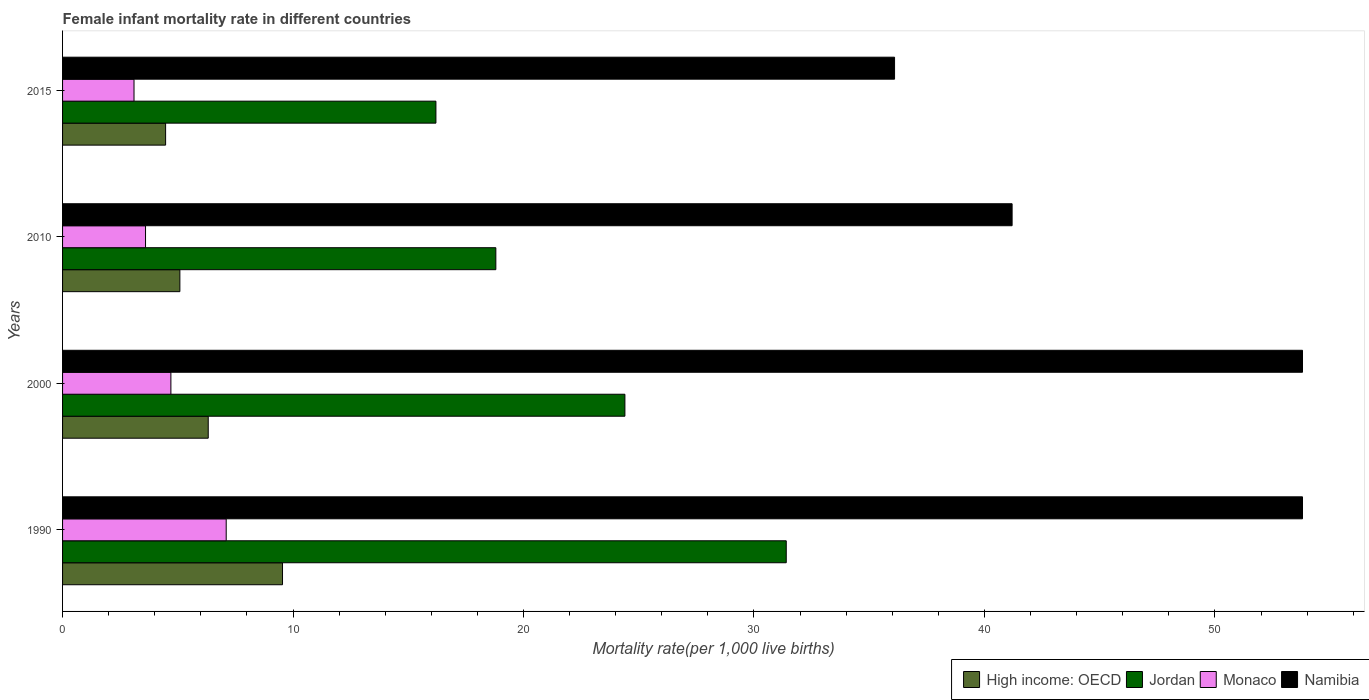How many different coloured bars are there?
Make the answer very short. 4. Are the number of bars per tick equal to the number of legend labels?
Make the answer very short. Yes. How many bars are there on the 3rd tick from the top?
Keep it short and to the point. 4. How many bars are there on the 2nd tick from the bottom?
Give a very brief answer. 4. What is the label of the 4th group of bars from the top?
Give a very brief answer. 1990. In how many cases, is the number of bars for a given year not equal to the number of legend labels?
Offer a terse response. 0. Across all years, what is the maximum female infant mortality rate in Monaco?
Provide a short and direct response. 7.1. Across all years, what is the minimum female infant mortality rate in High income: OECD?
Make the answer very short. 4.47. In which year was the female infant mortality rate in High income: OECD maximum?
Offer a terse response. 1990. In which year was the female infant mortality rate in High income: OECD minimum?
Provide a succinct answer. 2015. What is the total female infant mortality rate in High income: OECD in the graph?
Provide a succinct answer. 25.42. What is the difference between the female infant mortality rate in Jordan in 2000 and that in 2010?
Give a very brief answer. 5.6. What is the difference between the female infant mortality rate in Monaco in 1990 and the female infant mortality rate in Jordan in 2015?
Your answer should be very brief. -9.1. What is the average female infant mortality rate in Monaco per year?
Your response must be concise. 4.62. In the year 2000, what is the difference between the female infant mortality rate in Jordan and female infant mortality rate in High income: OECD?
Ensure brevity in your answer.  18.08. In how many years, is the female infant mortality rate in Namibia greater than 22 ?
Make the answer very short. 4. What is the ratio of the female infant mortality rate in Monaco in 1990 to that in 2010?
Ensure brevity in your answer.  1.97. Is the female infant mortality rate in Monaco in 1990 less than that in 2000?
Your answer should be compact. No. Is the difference between the female infant mortality rate in Jordan in 1990 and 2000 greater than the difference between the female infant mortality rate in High income: OECD in 1990 and 2000?
Provide a succinct answer. Yes. What is the difference between the highest and the second highest female infant mortality rate in Namibia?
Your answer should be compact. 0. What is the difference between the highest and the lowest female infant mortality rate in High income: OECD?
Give a very brief answer. 5.07. In how many years, is the female infant mortality rate in Jordan greater than the average female infant mortality rate in Jordan taken over all years?
Your response must be concise. 2. Is the sum of the female infant mortality rate in Namibia in 1990 and 2015 greater than the maximum female infant mortality rate in High income: OECD across all years?
Your answer should be very brief. Yes. What does the 2nd bar from the top in 2000 represents?
Give a very brief answer. Monaco. What does the 2nd bar from the bottom in 2010 represents?
Your answer should be compact. Jordan. Is it the case that in every year, the sum of the female infant mortality rate in Namibia and female infant mortality rate in High income: OECD is greater than the female infant mortality rate in Monaco?
Your answer should be very brief. Yes. How many bars are there?
Provide a short and direct response. 16. Are all the bars in the graph horizontal?
Offer a terse response. Yes. How many years are there in the graph?
Provide a succinct answer. 4. What is the difference between two consecutive major ticks on the X-axis?
Your answer should be compact. 10. Are the values on the major ticks of X-axis written in scientific E-notation?
Your answer should be very brief. No. Does the graph contain any zero values?
Your response must be concise. No. Does the graph contain grids?
Your response must be concise. No. What is the title of the graph?
Your answer should be compact. Female infant mortality rate in different countries. Does "Fragile and conflict affected situations" appear as one of the legend labels in the graph?
Your response must be concise. No. What is the label or title of the X-axis?
Keep it short and to the point. Mortality rate(per 1,0 live births). What is the Mortality rate(per 1,000 live births) of High income: OECD in 1990?
Your answer should be compact. 9.54. What is the Mortality rate(per 1,000 live births) of Jordan in 1990?
Keep it short and to the point. 31.4. What is the Mortality rate(per 1,000 live births) in Monaco in 1990?
Provide a short and direct response. 7.1. What is the Mortality rate(per 1,000 live births) in Namibia in 1990?
Your response must be concise. 53.8. What is the Mortality rate(per 1,000 live births) of High income: OECD in 2000?
Your response must be concise. 6.32. What is the Mortality rate(per 1,000 live births) in Jordan in 2000?
Your response must be concise. 24.4. What is the Mortality rate(per 1,000 live births) in Namibia in 2000?
Offer a very short reply. 53.8. What is the Mortality rate(per 1,000 live births) of High income: OECD in 2010?
Your response must be concise. 5.09. What is the Mortality rate(per 1,000 live births) of Jordan in 2010?
Keep it short and to the point. 18.8. What is the Mortality rate(per 1,000 live births) of Namibia in 2010?
Offer a very short reply. 41.2. What is the Mortality rate(per 1,000 live births) of High income: OECD in 2015?
Make the answer very short. 4.47. What is the Mortality rate(per 1,000 live births) in Jordan in 2015?
Your answer should be compact. 16.2. What is the Mortality rate(per 1,000 live births) in Namibia in 2015?
Your answer should be compact. 36.1. Across all years, what is the maximum Mortality rate(per 1,000 live births) in High income: OECD?
Offer a very short reply. 9.54. Across all years, what is the maximum Mortality rate(per 1,000 live births) of Jordan?
Your answer should be very brief. 31.4. Across all years, what is the maximum Mortality rate(per 1,000 live births) in Namibia?
Offer a very short reply. 53.8. Across all years, what is the minimum Mortality rate(per 1,000 live births) of High income: OECD?
Your answer should be compact. 4.47. Across all years, what is the minimum Mortality rate(per 1,000 live births) of Monaco?
Your response must be concise. 3.1. Across all years, what is the minimum Mortality rate(per 1,000 live births) of Namibia?
Your response must be concise. 36.1. What is the total Mortality rate(per 1,000 live births) in High income: OECD in the graph?
Your answer should be very brief. 25.42. What is the total Mortality rate(per 1,000 live births) in Jordan in the graph?
Your answer should be very brief. 90.8. What is the total Mortality rate(per 1,000 live births) in Namibia in the graph?
Offer a terse response. 184.9. What is the difference between the Mortality rate(per 1,000 live births) in High income: OECD in 1990 and that in 2000?
Provide a short and direct response. 3.22. What is the difference between the Mortality rate(per 1,000 live births) in Jordan in 1990 and that in 2000?
Offer a very short reply. 7. What is the difference between the Mortality rate(per 1,000 live births) in Monaco in 1990 and that in 2000?
Give a very brief answer. 2.4. What is the difference between the Mortality rate(per 1,000 live births) in Namibia in 1990 and that in 2000?
Provide a short and direct response. 0. What is the difference between the Mortality rate(per 1,000 live births) in High income: OECD in 1990 and that in 2010?
Your answer should be compact. 4.45. What is the difference between the Mortality rate(per 1,000 live births) of Jordan in 1990 and that in 2010?
Make the answer very short. 12.6. What is the difference between the Mortality rate(per 1,000 live births) of Monaco in 1990 and that in 2010?
Your answer should be compact. 3.5. What is the difference between the Mortality rate(per 1,000 live births) of Namibia in 1990 and that in 2010?
Provide a short and direct response. 12.6. What is the difference between the Mortality rate(per 1,000 live births) in High income: OECD in 1990 and that in 2015?
Keep it short and to the point. 5.07. What is the difference between the Mortality rate(per 1,000 live births) of Namibia in 1990 and that in 2015?
Offer a very short reply. 17.7. What is the difference between the Mortality rate(per 1,000 live births) of High income: OECD in 2000 and that in 2010?
Provide a succinct answer. 1.23. What is the difference between the Mortality rate(per 1,000 live births) in Namibia in 2000 and that in 2010?
Make the answer very short. 12.6. What is the difference between the Mortality rate(per 1,000 live births) in High income: OECD in 2000 and that in 2015?
Your answer should be very brief. 1.85. What is the difference between the Mortality rate(per 1,000 live births) in Namibia in 2000 and that in 2015?
Keep it short and to the point. 17.7. What is the difference between the Mortality rate(per 1,000 live births) of High income: OECD in 2010 and that in 2015?
Give a very brief answer. 0.62. What is the difference between the Mortality rate(per 1,000 live births) in Jordan in 2010 and that in 2015?
Provide a short and direct response. 2.6. What is the difference between the Mortality rate(per 1,000 live births) of High income: OECD in 1990 and the Mortality rate(per 1,000 live births) of Jordan in 2000?
Give a very brief answer. -14.86. What is the difference between the Mortality rate(per 1,000 live births) in High income: OECD in 1990 and the Mortality rate(per 1,000 live births) in Monaco in 2000?
Offer a very short reply. 4.84. What is the difference between the Mortality rate(per 1,000 live births) of High income: OECD in 1990 and the Mortality rate(per 1,000 live births) of Namibia in 2000?
Make the answer very short. -44.26. What is the difference between the Mortality rate(per 1,000 live births) in Jordan in 1990 and the Mortality rate(per 1,000 live births) in Monaco in 2000?
Your response must be concise. 26.7. What is the difference between the Mortality rate(per 1,000 live births) in Jordan in 1990 and the Mortality rate(per 1,000 live births) in Namibia in 2000?
Your answer should be very brief. -22.4. What is the difference between the Mortality rate(per 1,000 live births) in Monaco in 1990 and the Mortality rate(per 1,000 live births) in Namibia in 2000?
Provide a succinct answer. -46.7. What is the difference between the Mortality rate(per 1,000 live births) of High income: OECD in 1990 and the Mortality rate(per 1,000 live births) of Jordan in 2010?
Make the answer very short. -9.26. What is the difference between the Mortality rate(per 1,000 live births) in High income: OECD in 1990 and the Mortality rate(per 1,000 live births) in Monaco in 2010?
Offer a terse response. 5.94. What is the difference between the Mortality rate(per 1,000 live births) in High income: OECD in 1990 and the Mortality rate(per 1,000 live births) in Namibia in 2010?
Make the answer very short. -31.66. What is the difference between the Mortality rate(per 1,000 live births) of Jordan in 1990 and the Mortality rate(per 1,000 live births) of Monaco in 2010?
Keep it short and to the point. 27.8. What is the difference between the Mortality rate(per 1,000 live births) in Jordan in 1990 and the Mortality rate(per 1,000 live births) in Namibia in 2010?
Your answer should be very brief. -9.8. What is the difference between the Mortality rate(per 1,000 live births) in Monaco in 1990 and the Mortality rate(per 1,000 live births) in Namibia in 2010?
Keep it short and to the point. -34.1. What is the difference between the Mortality rate(per 1,000 live births) in High income: OECD in 1990 and the Mortality rate(per 1,000 live births) in Jordan in 2015?
Give a very brief answer. -6.66. What is the difference between the Mortality rate(per 1,000 live births) in High income: OECD in 1990 and the Mortality rate(per 1,000 live births) in Monaco in 2015?
Provide a succinct answer. 6.44. What is the difference between the Mortality rate(per 1,000 live births) of High income: OECD in 1990 and the Mortality rate(per 1,000 live births) of Namibia in 2015?
Make the answer very short. -26.56. What is the difference between the Mortality rate(per 1,000 live births) of Jordan in 1990 and the Mortality rate(per 1,000 live births) of Monaco in 2015?
Keep it short and to the point. 28.3. What is the difference between the Mortality rate(per 1,000 live births) in Jordan in 1990 and the Mortality rate(per 1,000 live births) in Namibia in 2015?
Give a very brief answer. -4.7. What is the difference between the Mortality rate(per 1,000 live births) in Monaco in 1990 and the Mortality rate(per 1,000 live births) in Namibia in 2015?
Keep it short and to the point. -29. What is the difference between the Mortality rate(per 1,000 live births) in High income: OECD in 2000 and the Mortality rate(per 1,000 live births) in Jordan in 2010?
Make the answer very short. -12.48. What is the difference between the Mortality rate(per 1,000 live births) in High income: OECD in 2000 and the Mortality rate(per 1,000 live births) in Monaco in 2010?
Your response must be concise. 2.72. What is the difference between the Mortality rate(per 1,000 live births) of High income: OECD in 2000 and the Mortality rate(per 1,000 live births) of Namibia in 2010?
Offer a terse response. -34.88. What is the difference between the Mortality rate(per 1,000 live births) in Jordan in 2000 and the Mortality rate(per 1,000 live births) in Monaco in 2010?
Give a very brief answer. 20.8. What is the difference between the Mortality rate(per 1,000 live births) of Jordan in 2000 and the Mortality rate(per 1,000 live births) of Namibia in 2010?
Your response must be concise. -16.8. What is the difference between the Mortality rate(per 1,000 live births) in Monaco in 2000 and the Mortality rate(per 1,000 live births) in Namibia in 2010?
Keep it short and to the point. -36.5. What is the difference between the Mortality rate(per 1,000 live births) of High income: OECD in 2000 and the Mortality rate(per 1,000 live births) of Jordan in 2015?
Your response must be concise. -9.88. What is the difference between the Mortality rate(per 1,000 live births) in High income: OECD in 2000 and the Mortality rate(per 1,000 live births) in Monaco in 2015?
Provide a short and direct response. 3.22. What is the difference between the Mortality rate(per 1,000 live births) of High income: OECD in 2000 and the Mortality rate(per 1,000 live births) of Namibia in 2015?
Give a very brief answer. -29.78. What is the difference between the Mortality rate(per 1,000 live births) of Jordan in 2000 and the Mortality rate(per 1,000 live births) of Monaco in 2015?
Ensure brevity in your answer.  21.3. What is the difference between the Mortality rate(per 1,000 live births) of Jordan in 2000 and the Mortality rate(per 1,000 live births) of Namibia in 2015?
Your answer should be compact. -11.7. What is the difference between the Mortality rate(per 1,000 live births) of Monaco in 2000 and the Mortality rate(per 1,000 live births) of Namibia in 2015?
Offer a very short reply. -31.4. What is the difference between the Mortality rate(per 1,000 live births) in High income: OECD in 2010 and the Mortality rate(per 1,000 live births) in Jordan in 2015?
Provide a short and direct response. -11.11. What is the difference between the Mortality rate(per 1,000 live births) of High income: OECD in 2010 and the Mortality rate(per 1,000 live births) of Monaco in 2015?
Keep it short and to the point. 1.99. What is the difference between the Mortality rate(per 1,000 live births) in High income: OECD in 2010 and the Mortality rate(per 1,000 live births) in Namibia in 2015?
Your answer should be compact. -31.01. What is the difference between the Mortality rate(per 1,000 live births) in Jordan in 2010 and the Mortality rate(per 1,000 live births) in Namibia in 2015?
Your answer should be compact. -17.3. What is the difference between the Mortality rate(per 1,000 live births) of Monaco in 2010 and the Mortality rate(per 1,000 live births) of Namibia in 2015?
Offer a very short reply. -32.5. What is the average Mortality rate(per 1,000 live births) of High income: OECD per year?
Give a very brief answer. 6.36. What is the average Mortality rate(per 1,000 live births) in Jordan per year?
Ensure brevity in your answer.  22.7. What is the average Mortality rate(per 1,000 live births) of Monaco per year?
Provide a short and direct response. 4.62. What is the average Mortality rate(per 1,000 live births) in Namibia per year?
Ensure brevity in your answer.  46.23. In the year 1990, what is the difference between the Mortality rate(per 1,000 live births) of High income: OECD and Mortality rate(per 1,000 live births) of Jordan?
Provide a short and direct response. -21.86. In the year 1990, what is the difference between the Mortality rate(per 1,000 live births) of High income: OECD and Mortality rate(per 1,000 live births) of Monaco?
Offer a very short reply. 2.44. In the year 1990, what is the difference between the Mortality rate(per 1,000 live births) in High income: OECD and Mortality rate(per 1,000 live births) in Namibia?
Give a very brief answer. -44.26. In the year 1990, what is the difference between the Mortality rate(per 1,000 live births) of Jordan and Mortality rate(per 1,000 live births) of Monaco?
Make the answer very short. 24.3. In the year 1990, what is the difference between the Mortality rate(per 1,000 live births) in Jordan and Mortality rate(per 1,000 live births) in Namibia?
Make the answer very short. -22.4. In the year 1990, what is the difference between the Mortality rate(per 1,000 live births) in Monaco and Mortality rate(per 1,000 live births) in Namibia?
Your answer should be very brief. -46.7. In the year 2000, what is the difference between the Mortality rate(per 1,000 live births) of High income: OECD and Mortality rate(per 1,000 live births) of Jordan?
Make the answer very short. -18.08. In the year 2000, what is the difference between the Mortality rate(per 1,000 live births) of High income: OECD and Mortality rate(per 1,000 live births) of Monaco?
Your response must be concise. 1.62. In the year 2000, what is the difference between the Mortality rate(per 1,000 live births) of High income: OECD and Mortality rate(per 1,000 live births) of Namibia?
Your answer should be compact. -47.48. In the year 2000, what is the difference between the Mortality rate(per 1,000 live births) in Jordan and Mortality rate(per 1,000 live births) in Monaco?
Your answer should be compact. 19.7. In the year 2000, what is the difference between the Mortality rate(per 1,000 live births) of Jordan and Mortality rate(per 1,000 live births) of Namibia?
Make the answer very short. -29.4. In the year 2000, what is the difference between the Mortality rate(per 1,000 live births) in Monaco and Mortality rate(per 1,000 live births) in Namibia?
Provide a short and direct response. -49.1. In the year 2010, what is the difference between the Mortality rate(per 1,000 live births) of High income: OECD and Mortality rate(per 1,000 live births) of Jordan?
Your answer should be very brief. -13.71. In the year 2010, what is the difference between the Mortality rate(per 1,000 live births) of High income: OECD and Mortality rate(per 1,000 live births) of Monaco?
Ensure brevity in your answer.  1.49. In the year 2010, what is the difference between the Mortality rate(per 1,000 live births) of High income: OECD and Mortality rate(per 1,000 live births) of Namibia?
Your answer should be very brief. -36.11. In the year 2010, what is the difference between the Mortality rate(per 1,000 live births) of Jordan and Mortality rate(per 1,000 live births) of Namibia?
Keep it short and to the point. -22.4. In the year 2010, what is the difference between the Mortality rate(per 1,000 live births) in Monaco and Mortality rate(per 1,000 live births) in Namibia?
Offer a very short reply. -37.6. In the year 2015, what is the difference between the Mortality rate(per 1,000 live births) in High income: OECD and Mortality rate(per 1,000 live births) in Jordan?
Your answer should be very brief. -11.73. In the year 2015, what is the difference between the Mortality rate(per 1,000 live births) of High income: OECD and Mortality rate(per 1,000 live births) of Monaco?
Offer a terse response. 1.37. In the year 2015, what is the difference between the Mortality rate(per 1,000 live births) of High income: OECD and Mortality rate(per 1,000 live births) of Namibia?
Offer a terse response. -31.63. In the year 2015, what is the difference between the Mortality rate(per 1,000 live births) of Jordan and Mortality rate(per 1,000 live births) of Namibia?
Offer a terse response. -19.9. In the year 2015, what is the difference between the Mortality rate(per 1,000 live births) in Monaco and Mortality rate(per 1,000 live births) in Namibia?
Offer a very short reply. -33. What is the ratio of the Mortality rate(per 1,000 live births) in High income: OECD in 1990 to that in 2000?
Offer a terse response. 1.51. What is the ratio of the Mortality rate(per 1,000 live births) of Jordan in 1990 to that in 2000?
Ensure brevity in your answer.  1.29. What is the ratio of the Mortality rate(per 1,000 live births) of Monaco in 1990 to that in 2000?
Give a very brief answer. 1.51. What is the ratio of the Mortality rate(per 1,000 live births) in High income: OECD in 1990 to that in 2010?
Offer a very short reply. 1.88. What is the ratio of the Mortality rate(per 1,000 live births) of Jordan in 1990 to that in 2010?
Keep it short and to the point. 1.67. What is the ratio of the Mortality rate(per 1,000 live births) of Monaco in 1990 to that in 2010?
Provide a succinct answer. 1.97. What is the ratio of the Mortality rate(per 1,000 live births) of Namibia in 1990 to that in 2010?
Provide a succinct answer. 1.31. What is the ratio of the Mortality rate(per 1,000 live births) in High income: OECD in 1990 to that in 2015?
Keep it short and to the point. 2.13. What is the ratio of the Mortality rate(per 1,000 live births) of Jordan in 1990 to that in 2015?
Provide a short and direct response. 1.94. What is the ratio of the Mortality rate(per 1,000 live births) in Monaco in 1990 to that in 2015?
Your answer should be compact. 2.29. What is the ratio of the Mortality rate(per 1,000 live births) in Namibia in 1990 to that in 2015?
Keep it short and to the point. 1.49. What is the ratio of the Mortality rate(per 1,000 live births) of High income: OECD in 2000 to that in 2010?
Ensure brevity in your answer.  1.24. What is the ratio of the Mortality rate(per 1,000 live births) of Jordan in 2000 to that in 2010?
Keep it short and to the point. 1.3. What is the ratio of the Mortality rate(per 1,000 live births) of Monaco in 2000 to that in 2010?
Make the answer very short. 1.31. What is the ratio of the Mortality rate(per 1,000 live births) in Namibia in 2000 to that in 2010?
Offer a terse response. 1.31. What is the ratio of the Mortality rate(per 1,000 live births) in High income: OECD in 2000 to that in 2015?
Offer a terse response. 1.41. What is the ratio of the Mortality rate(per 1,000 live births) of Jordan in 2000 to that in 2015?
Keep it short and to the point. 1.51. What is the ratio of the Mortality rate(per 1,000 live births) in Monaco in 2000 to that in 2015?
Your answer should be compact. 1.52. What is the ratio of the Mortality rate(per 1,000 live births) in Namibia in 2000 to that in 2015?
Your answer should be compact. 1.49. What is the ratio of the Mortality rate(per 1,000 live births) in High income: OECD in 2010 to that in 2015?
Provide a succinct answer. 1.14. What is the ratio of the Mortality rate(per 1,000 live births) of Jordan in 2010 to that in 2015?
Offer a terse response. 1.16. What is the ratio of the Mortality rate(per 1,000 live births) of Monaco in 2010 to that in 2015?
Offer a terse response. 1.16. What is the ratio of the Mortality rate(per 1,000 live births) of Namibia in 2010 to that in 2015?
Offer a terse response. 1.14. What is the difference between the highest and the second highest Mortality rate(per 1,000 live births) in High income: OECD?
Provide a short and direct response. 3.22. What is the difference between the highest and the second highest Mortality rate(per 1,000 live births) in Namibia?
Provide a succinct answer. 0. What is the difference between the highest and the lowest Mortality rate(per 1,000 live births) of High income: OECD?
Offer a terse response. 5.07. What is the difference between the highest and the lowest Mortality rate(per 1,000 live births) in Jordan?
Make the answer very short. 15.2. 